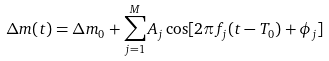<formula> <loc_0><loc_0><loc_500><loc_500>\Delta m ( t ) = \Delta m _ { 0 } + \sum _ { j = 1 } ^ { M } A _ { j } \cos [ 2 \pi f _ { j } ( t - T _ { 0 } ) + \phi _ { j } ]</formula> 